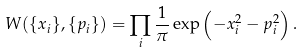Convert formula to latex. <formula><loc_0><loc_0><loc_500><loc_500>W ( \{ x _ { i } \} , \{ p _ { i } \} ) = \prod _ { i } \frac { 1 } { \pi } \exp \left ( - x _ { i } ^ { 2 } - p _ { i } ^ { 2 } \right ) .</formula> 